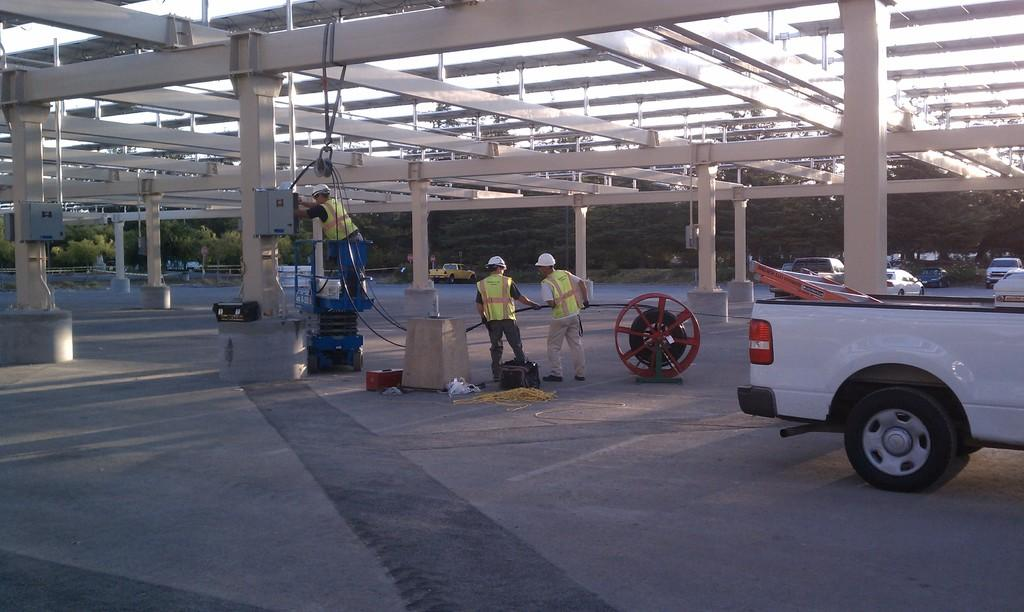What are the people in the image holding? The people in the image are holding objects. What can be seen on the ground in the image? There are spoke objects visible on the ground in the image. What types of vehicles are present in the image? There are vehicles in the image. What architectural features can be seen in the image? There are pillars in the image. What other structures are present in the image? There are poles in the image. What type of vegetation is visible in the image? There are trees in the image. What part of the natural environment is visible in the image? The sky is visible in the image. What type of paint is used to design the linen in the image? There is no paint, design, or linen present in the image. 